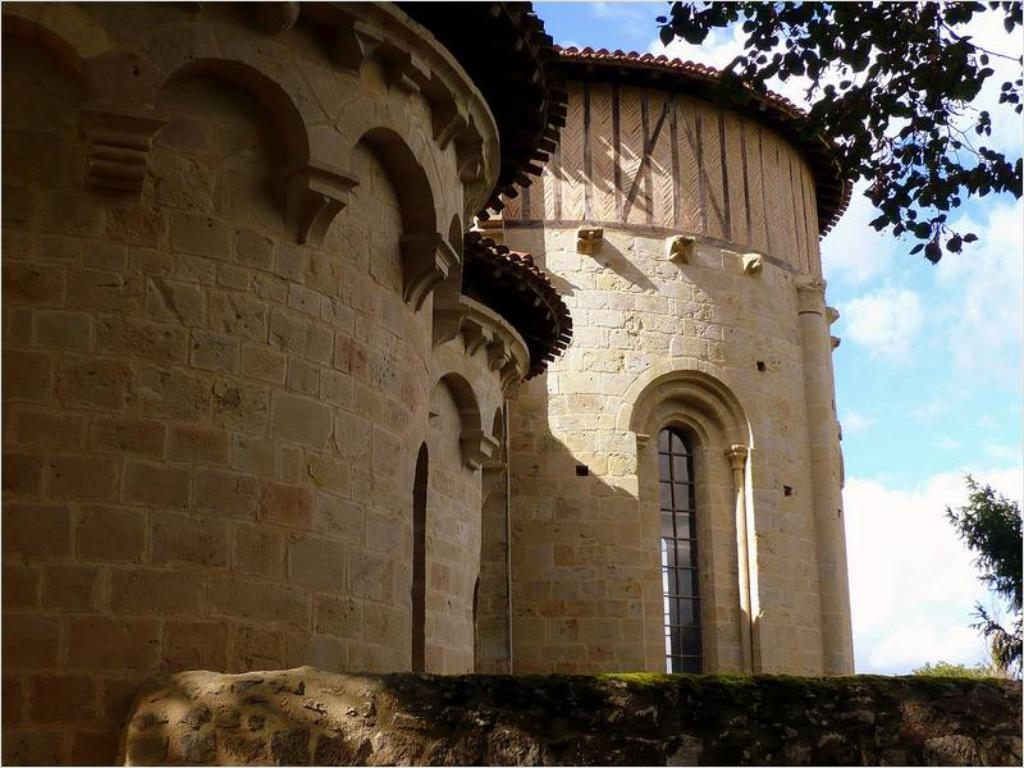What is the main structure in the image? There is a building in the image. What can be seen in front of the building? There are trees in front of the building. What is visible in the background of the image? The sky is visible in the background of the image. What type of yarn is hanging from the branches of the trees in the image? There is no yarn present in the image; only trees are visible in front of the building. 